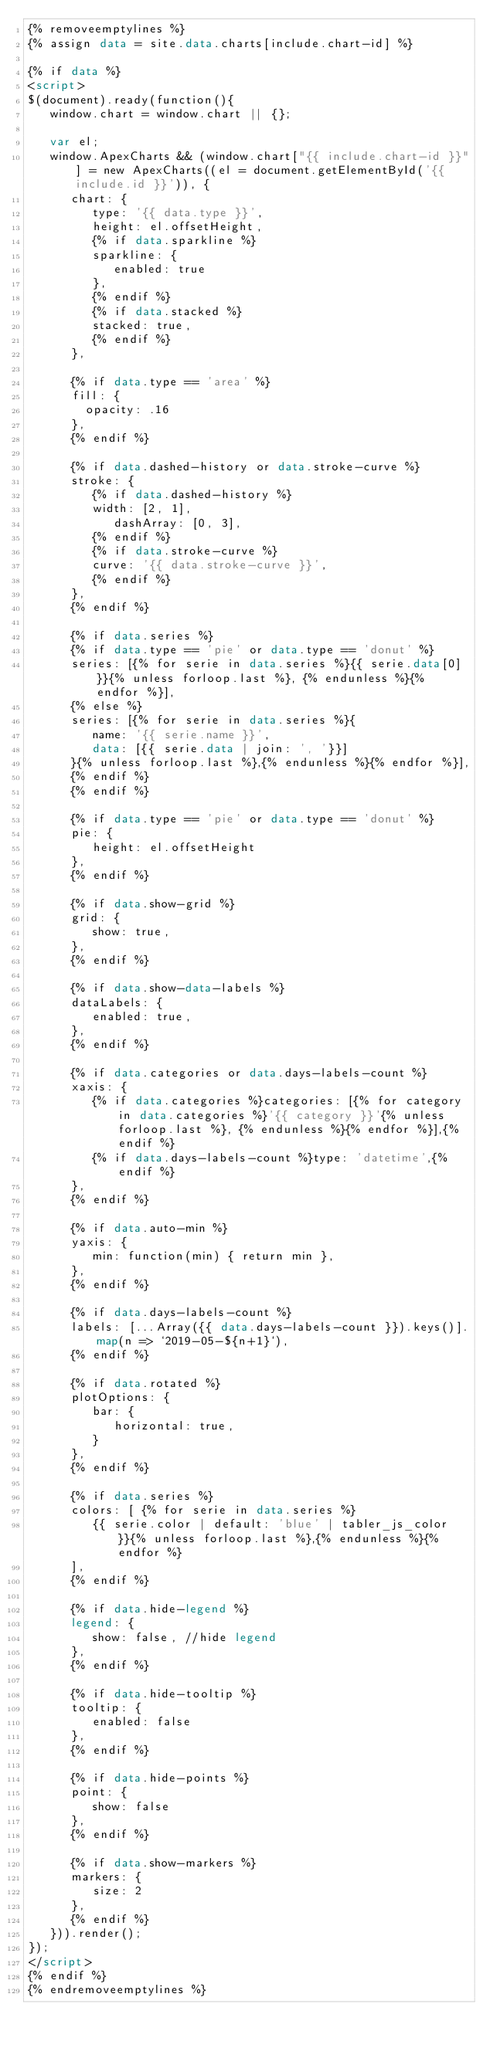Convert code to text. <code><loc_0><loc_0><loc_500><loc_500><_HTML_>{% removeemptylines %}
{% assign data = site.data.charts[include.chart-id] %}

{% if data %}
<script>
$(document).ready(function(){
   window.chart = window.chart || {};
   
   var el;
   window.ApexCharts && (window.chart["{{ include.chart-id }}"] = new ApexCharts((el = document.getElementById('{{ include.id }}')), {
      chart: {
         type: '{{ data.type }}',
         height: el.offsetHeight,
         {% if data.sparkline %}
         sparkline: {
            enabled: true
         },
         {% endif %}
         {% if data.stacked %}
         stacked: true,
         {% endif %}
      },

      {% if data.type == 'area' %}
      fill: {
        opacity: .16
      },
      {% endif %}

      {% if data.dashed-history or data.stroke-curve %}
      stroke: {
         {% if data.dashed-history %}
         width: [2, 1],
            dashArray: [0, 3],
         {% endif %}
         {% if data.stroke-curve %}
         curve: '{{ data.stroke-curve }}',
         {% endif %}
      },
      {% endif %}

      {% if data.series %}
      {% if data.type == 'pie' or data.type == 'donut' %}
      series: [{% for serie in data.series %}{{ serie.data[0] }}{% unless forloop.last %}, {% endunless %}{% endfor %}],
      {% else %}
      series: [{% for serie in data.series %}{
         name: '{{ serie.name }}',
         data: [{{ serie.data | join: ', '}}]
      }{% unless forloop.last %},{% endunless %}{% endfor %}],
      {% endif %}
      {% endif %}

      {% if data.type == 'pie' or data.type == 'donut' %}
      pie: {
         height: el.offsetHeight
      },
      {% endif %}

      {% if data.show-grid %}
      grid: {
         show: true,
      },
      {% endif %}

      {% if data.show-data-labels %}
      dataLabels: {
         enabled: true,
      },
      {% endif %}

      {% if data.categories or data.days-labels-count %}
      xaxis: {
         {% if data.categories %}categories: [{% for category in data.categories %}'{{ category }}'{% unless forloop.last %}, {% endunless %}{% endfor %}],{% endif %}
         {% if data.days-labels-count %}type: 'datetime',{% endif %}
      },
      {% endif %}

      {% if data.auto-min %}
      yaxis: {
         min: function(min) { return min },
      },
      {% endif %}

      {% if data.days-labels-count %}
      labels: [...Array({{ data.days-labels-count }}).keys()].map(n => `2019-05-${n+1}`),
      {% endif %}

      {% if data.rotated %}
      plotOptions: {
         bar: {
            horizontal: true,
         }
      },
      {% endif %}

      {% if data.series %}
      colors: [ {% for serie in data.series %}
         {{ serie.color | default: 'blue' | tabler_js_color }}{% unless forloop.last %},{% endunless %}{% endfor %}
      ],
      {% endif %}

      {% if data.hide-legend %}
      legend: {
         show: false, //hide legend
      },
      {% endif %}

      {% if data.hide-tooltip %}
      tooltip: {
         enabled: false
      },
      {% endif %}

      {% if data.hide-points %}
      point: {
         show: false
      },
      {% endif %}

      {% if data.show-markers %}
      markers: {
         size: 2
      },
      {% endif %}
   })).render();
});
</script>
{% endif %}
{% endremoveemptylines %}
</code> 